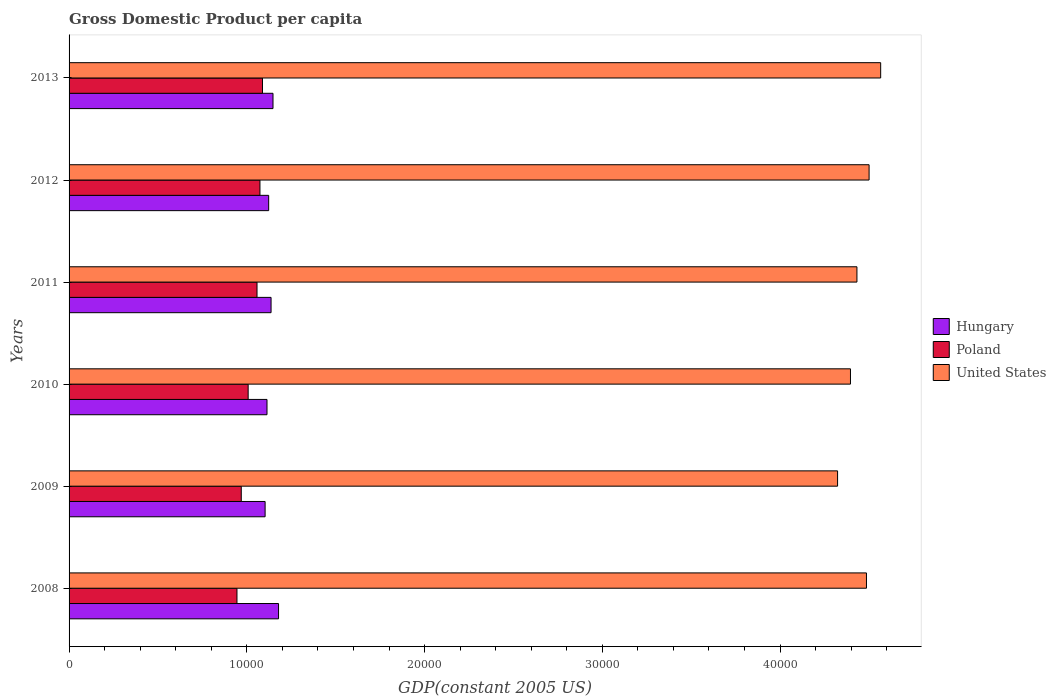Are the number of bars on each tick of the Y-axis equal?
Provide a short and direct response. Yes. How many bars are there on the 3rd tick from the top?
Your answer should be very brief. 3. How many bars are there on the 2nd tick from the bottom?
Offer a very short reply. 3. In how many cases, is the number of bars for a given year not equal to the number of legend labels?
Keep it short and to the point. 0. What is the GDP per capita in United States in 2011?
Provide a succinct answer. 4.43e+04. Across all years, what is the maximum GDP per capita in Poland?
Your answer should be compact. 1.09e+04. Across all years, what is the minimum GDP per capita in Hungary?
Provide a short and direct response. 1.10e+04. In which year was the GDP per capita in Poland minimum?
Make the answer very short. 2008. What is the total GDP per capita in Poland in the graph?
Offer a terse response. 6.14e+04. What is the difference between the GDP per capita in United States in 2009 and that in 2011?
Make the answer very short. -1089.39. What is the difference between the GDP per capita in Poland in 2009 and the GDP per capita in United States in 2013?
Provide a short and direct response. -3.60e+04. What is the average GDP per capita in Hungary per year?
Keep it short and to the point. 1.13e+04. In the year 2009, what is the difference between the GDP per capita in United States and GDP per capita in Poland?
Ensure brevity in your answer.  3.35e+04. What is the ratio of the GDP per capita in Poland in 2008 to that in 2012?
Keep it short and to the point. 0.88. Is the GDP per capita in Hungary in 2010 less than that in 2011?
Offer a very short reply. Yes. Is the difference between the GDP per capita in United States in 2010 and 2011 greater than the difference between the GDP per capita in Poland in 2010 and 2011?
Your answer should be very brief. Yes. What is the difference between the highest and the second highest GDP per capita in United States?
Offer a very short reply. 652.12. What is the difference between the highest and the lowest GDP per capita in United States?
Your answer should be compact. 2425.18. Is the sum of the GDP per capita in Hungary in 2009 and 2012 greater than the maximum GDP per capita in Poland across all years?
Provide a short and direct response. Yes. What does the 1st bar from the top in 2010 represents?
Offer a terse response. United States. What does the 2nd bar from the bottom in 2010 represents?
Your answer should be very brief. Poland. What is the difference between two consecutive major ticks on the X-axis?
Provide a short and direct response. 10000. Does the graph contain grids?
Keep it short and to the point. No. Where does the legend appear in the graph?
Your answer should be compact. Center right. How are the legend labels stacked?
Your answer should be very brief. Vertical. What is the title of the graph?
Your answer should be very brief. Gross Domestic Product per capita. Does "Greece" appear as one of the legend labels in the graph?
Offer a terse response. No. What is the label or title of the X-axis?
Keep it short and to the point. GDP(constant 2005 US). What is the label or title of the Y-axis?
Keep it short and to the point. Years. What is the GDP(constant 2005 US) in Hungary in 2008?
Make the answer very short. 1.18e+04. What is the GDP(constant 2005 US) in Poland in 2008?
Offer a very short reply. 9445.78. What is the GDP(constant 2005 US) in United States in 2008?
Ensure brevity in your answer.  4.49e+04. What is the GDP(constant 2005 US) of Hungary in 2009?
Ensure brevity in your answer.  1.10e+04. What is the GDP(constant 2005 US) of Poland in 2009?
Ensure brevity in your answer.  9688.03. What is the GDP(constant 2005 US) in United States in 2009?
Ensure brevity in your answer.  4.32e+04. What is the GDP(constant 2005 US) of Hungary in 2010?
Your answer should be compact. 1.11e+04. What is the GDP(constant 2005 US) in Poland in 2010?
Your answer should be compact. 1.01e+04. What is the GDP(constant 2005 US) in United States in 2010?
Give a very brief answer. 4.40e+04. What is the GDP(constant 2005 US) of Hungary in 2011?
Offer a very short reply. 1.14e+04. What is the GDP(constant 2005 US) in Poland in 2011?
Your answer should be very brief. 1.06e+04. What is the GDP(constant 2005 US) of United States in 2011?
Give a very brief answer. 4.43e+04. What is the GDP(constant 2005 US) in Hungary in 2012?
Give a very brief answer. 1.12e+04. What is the GDP(constant 2005 US) in Poland in 2012?
Your answer should be very brief. 1.07e+04. What is the GDP(constant 2005 US) in United States in 2012?
Offer a terse response. 4.50e+04. What is the GDP(constant 2005 US) in Hungary in 2013?
Keep it short and to the point. 1.15e+04. What is the GDP(constant 2005 US) of Poland in 2013?
Your answer should be very brief. 1.09e+04. What is the GDP(constant 2005 US) in United States in 2013?
Ensure brevity in your answer.  4.57e+04. Across all years, what is the maximum GDP(constant 2005 US) of Hungary?
Give a very brief answer. 1.18e+04. Across all years, what is the maximum GDP(constant 2005 US) in Poland?
Provide a short and direct response. 1.09e+04. Across all years, what is the maximum GDP(constant 2005 US) of United States?
Keep it short and to the point. 4.57e+04. Across all years, what is the minimum GDP(constant 2005 US) of Hungary?
Offer a terse response. 1.10e+04. Across all years, what is the minimum GDP(constant 2005 US) of Poland?
Give a very brief answer. 9445.78. Across all years, what is the minimum GDP(constant 2005 US) in United States?
Offer a terse response. 4.32e+04. What is the total GDP(constant 2005 US) in Hungary in the graph?
Ensure brevity in your answer.  6.80e+04. What is the total GDP(constant 2005 US) of Poland in the graph?
Keep it short and to the point. 6.14e+04. What is the total GDP(constant 2005 US) of United States in the graph?
Give a very brief answer. 2.67e+05. What is the difference between the GDP(constant 2005 US) in Hungary in 2008 and that in 2009?
Offer a very short reply. 755.89. What is the difference between the GDP(constant 2005 US) of Poland in 2008 and that in 2009?
Make the answer very short. -242.25. What is the difference between the GDP(constant 2005 US) of United States in 2008 and that in 2009?
Give a very brief answer. 1625.83. What is the difference between the GDP(constant 2005 US) in Hungary in 2008 and that in 2010?
Your response must be concise. 648.79. What is the difference between the GDP(constant 2005 US) in Poland in 2008 and that in 2010?
Offer a terse response. -629.33. What is the difference between the GDP(constant 2005 US) of United States in 2008 and that in 2010?
Provide a succinct answer. 900.22. What is the difference between the GDP(constant 2005 US) of Hungary in 2008 and that in 2011?
Offer a very short reply. 420.92. What is the difference between the GDP(constant 2005 US) of Poland in 2008 and that in 2011?
Offer a terse response. -1128.26. What is the difference between the GDP(constant 2005 US) of United States in 2008 and that in 2011?
Offer a terse response. 536.45. What is the difference between the GDP(constant 2005 US) of Hungary in 2008 and that in 2012?
Your response must be concise. 555. What is the difference between the GDP(constant 2005 US) of Poland in 2008 and that in 2012?
Give a very brief answer. -1293.42. What is the difference between the GDP(constant 2005 US) in United States in 2008 and that in 2012?
Ensure brevity in your answer.  -147.22. What is the difference between the GDP(constant 2005 US) of Hungary in 2008 and that in 2013?
Make the answer very short. 311.23. What is the difference between the GDP(constant 2005 US) in Poland in 2008 and that in 2013?
Make the answer very short. -1435.81. What is the difference between the GDP(constant 2005 US) of United States in 2008 and that in 2013?
Your answer should be very brief. -799.34. What is the difference between the GDP(constant 2005 US) in Hungary in 2009 and that in 2010?
Offer a terse response. -107.11. What is the difference between the GDP(constant 2005 US) of Poland in 2009 and that in 2010?
Make the answer very short. -387.08. What is the difference between the GDP(constant 2005 US) of United States in 2009 and that in 2010?
Give a very brief answer. -725.61. What is the difference between the GDP(constant 2005 US) of Hungary in 2009 and that in 2011?
Ensure brevity in your answer.  -334.97. What is the difference between the GDP(constant 2005 US) in Poland in 2009 and that in 2011?
Offer a very short reply. -886.01. What is the difference between the GDP(constant 2005 US) of United States in 2009 and that in 2011?
Give a very brief answer. -1089.39. What is the difference between the GDP(constant 2005 US) of Hungary in 2009 and that in 2012?
Offer a terse response. -200.9. What is the difference between the GDP(constant 2005 US) in Poland in 2009 and that in 2012?
Your answer should be compact. -1051.17. What is the difference between the GDP(constant 2005 US) in United States in 2009 and that in 2012?
Your answer should be very brief. -1773.06. What is the difference between the GDP(constant 2005 US) in Hungary in 2009 and that in 2013?
Offer a very short reply. -444.66. What is the difference between the GDP(constant 2005 US) of Poland in 2009 and that in 2013?
Offer a terse response. -1193.55. What is the difference between the GDP(constant 2005 US) in United States in 2009 and that in 2013?
Your answer should be compact. -2425.18. What is the difference between the GDP(constant 2005 US) in Hungary in 2010 and that in 2011?
Your response must be concise. -227.87. What is the difference between the GDP(constant 2005 US) of Poland in 2010 and that in 2011?
Give a very brief answer. -498.93. What is the difference between the GDP(constant 2005 US) in United States in 2010 and that in 2011?
Make the answer very short. -363.78. What is the difference between the GDP(constant 2005 US) of Hungary in 2010 and that in 2012?
Offer a very short reply. -93.79. What is the difference between the GDP(constant 2005 US) in Poland in 2010 and that in 2012?
Provide a succinct answer. -664.09. What is the difference between the GDP(constant 2005 US) of United States in 2010 and that in 2012?
Provide a succinct answer. -1047.45. What is the difference between the GDP(constant 2005 US) in Hungary in 2010 and that in 2013?
Make the answer very short. -337.56. What is the difference between the GDP(constant 2005 US) in Poland in 2010 and that in 2013?
Offer a very short reply. -806.47. What is the difference between the GDP(constant 2005 US) of United States in 2010 and that in 2013?
Give a very brief answer. -1699.57. What is the difference between the GDP(constant 2005 US) of Hungary in 2011 and that in 2012?
Provide a short and direct response. 134.08. What is the difference between the GDP(constant 2005 US) in Poland in 2011 and that in 2012?
Offer a terse response. -165.16. What is the difference between the GDP(constant 2005 US) in United States in 2011 and that in 2012?
Provide a short and direct response. -683.67. What is the difference between the GDP(constant 2005 US) of Hungary in 2011 and that in 2013?
Your response must be concise. -109.69. What is the difference between the GDP(constant 2005 US) in Poland in 2011 and that in 2013?
Ensure brevity in your answer.  -307.55. What is the difference between the GDP(constant 2005 US) in United States in 2011 and that in 2013?
Make the answer very short. -1335.79. What is the difference between the GDP(constant 2005 US) in Hungary in 2012 and that in 2013?
Your answer should be compact. -243.76. What is the difference between the GDP(constant 2005 US) in Poland in 2012 and that in 2013?
Your answer should be compact. -142.39. What is the difference between the GDP(constant 2005 US) in United States in 2012 and that in 2013?
Your answer should be compact. -652.12. What is the difference between the GDP(constant 2005 US) of Hungary in 2008 and the GDP(constant 2005 US) of Poland in 2009?
Offer a very short reply. 2096.6. What is the difference between the GDP(constant 2005 US) in Hungary in 2008 and the GDP(constant 2005 US) in United States in 2009?
Ensure brevity in your answer.  -3.15e+04. What is the difference between the GDP(constant 2005 US) in Poland in 2008 and the GDP(constant 2005 US) in United States in 2009?
Provide a succinct answer. -3.38e+04. What is the difference between the GDP(constant 2005 US) in Hungary in 2008 and the GDP(constant 2005 US) in Poland in 2010?
Your response must be concise. 1709.52. What is the difference between the GDP(constant 2005 US) of Hungary in 2008 and the GDP(constant 2005 US) of United States in 2010?
Keep it short and to the point. -3.22e+04. What is the difference between the GDP(constant 2005 US) of Poland in 2008 and the GDP(constant 2005 US) of United States in 2010?
Provide a short and direct response. -3.45e+04. What is the difference between the GDP(constant 2005 US) of Hungary in 2008 and the GDP(constant 2005 US) of Poland in 2011?
Your answer should be compact. 1210.59. What is the difference between the GDP(constant 2005 US) of Hungary in 2008 and the GDP(constant 2005 US) of United States in 2011?
Your answer should be compact. -3.25e+04. What is the difference between the GDP(constant 2005 US) of Poland in 2008 and the GDP(constant 2005 US) of United States in 2011?
Make the answer very short. -3.49e+04. What is the difference between the GDP(constant 2005 US) in Hungary in 2008 and the GDP(constant 2005 US) in Poland in 2012?
Your answer should be very brief. 1045.43. What is the difference between the GDP(constant 2005 US) in Hungary in 2008 and the GDP(constant 2005 US) in United States in 2012?
Your answer should be very brief. -3.32e+04. What is the difference between the GDP(constant 2005 US) in Poland in 2008 and the GDP(constant 2005 US) in United States in 2012?
Your answer should be very brief. -3.56e+04. What is the difference between the GDP(constant 2005 US) of Hungary in 2008 and the GDP(constant 2005 US) of Poland in 2013?
Provide a short and direct response. 903.04. What is the difference between the GDP(constant 2005 US) in Hungary in 2008 and the GDP(constant 2005 US) in United States in 2013?
Give a very brief answer. -3.39e+04. What is the difference between the GDP(constant 2005 US) of Poland in 2008 and the GDP(constant 2005 US) of United States in 2013?
Ensure brevity in your answer.  -3.62e+04. What is the difference between the GDP(constant 2005 US) in Hungary in 2009 and the GDP(constant 2005 US) in Poland in 2010?
Make the answer very short. 953.62. What is the difference between the GDP(constant 2005 US) of Hungary in 2009 and the GDP(constant 2005 US) of United States in 2010?
Provide a succinct answer. -3.29e+04. What is the difference between the GDP(constant 2005 US) in Poland in 2009 and the GDP(constant 2005 US) in United States in 2010?
Your answer should be compact. -3.43e+04. What is the difference between the GDP(constant 2005 US) of Hungary in 2009 and the GDP(constant 2005 US) of Poland in 2011?
Offer a very short reply. 454.7. What is the difference between the GDP(constant 2005 US) of Hungary in 2009 and the GDP(constant 2005 US) of United States in 2011?
Give a very brief answer. -3.33e+04. What is the difference between the GDP(constant 2005 US) of Poland in 2009 and the GDP(constant 2005 US) of United States in 2011?
Provide a short and direct response. -3.46e+04. What is the difference between the GDP(constant 2005 US) in Hungary in 2009 and the GDP(constant 2005 US) in Poland in 2012?
Your answer should be compact. 289.54. What is the difference between the GDP(constant 2005 US) of Hungary in 2009 and the GDP(constant 2005 US) of United States in 2012?
Make the answer very short. -3.40e+04. What is the difference between the GDP(constant 2005 US) in Poland in 2009 and the GDP(constant 2005 US) in United States in 2012?
Give a very brief answer. -3.53e+04. What is the difference between the GDP(constant 2005 US) in Hungary in 2009 and the GDP(constant 2005 US) in Poland in 2013?
Keep it short and to the point. 147.15. What is the difference between the GDP(constant 2005 US) in Hungary in 2009 and the GDP(constant 2005 US) in United States in 2013?
Provide a short and direct response. -3.46e+04. What is the difference between the GDP(constant 2005 US) of Poland in 2009 and the GDP(constant 2005 US) of United States in 2013?
Provide a succinct answer. -3.60e+04. What is the difference between the GDP(constant 2005 US) of Hungary in 2010 and the GDP(constant 2005 US) of Poland in 2011?
Offer a terse response. 561.8. What is the difference between the GDP(constant 2005 US) of Hungary in 2010 and the GDP(constant 2005 US) of United States in 2011?
Provide a succinct answer. -3.32e+04. What is the difference between the GDP(constant 2005 US) of Poland in 2010 and the GDP(constant 2005 US) of United States in 2011?
Your answer should be compact. -3.42e+04. What is the difference between the GDP(constant 2005 US) in Hungary in 2010 and the GDP(constant 2005 US) in Poland in 2012?
Offer a terse response. 396.64. What is the difference between the GDP(constant 2005 US) in Hungary in 2010 and the GDP(constant 2005 US) in United States in 2012?
Your response must be concise. -3.39e+04. What is the difference between the GDP(constant 2005 US) in Poland in 2010 and the GDP(constant 2005 US) in United States in 2012?
Keep it short and to the point. -3.49e+04. What is the difference between the GDP(constant 2005 US) in Hungary in 2010 and the GDP(constant 2005 US) in Poland in 2013?
Your response must be concise. 254.25. What is the difference between the GDP(constant 2005 US) of Hungary in 2010 and the GDP(constant 2005 US) of United States in 2013?
Make the answer very short. -3.45e+04. What is the difference between the GDP(constant 2005 US) in Poland in 2010 and the GDP(constant 2005 US) in United States in 2013?
Ensure brevity in your answer.  -3.56e+04. What is the difference between the GDP(constant 2005 US) of Hungary in 2011 and the GDP(constant 2005 US) of Poland in 2012?
Offer a terse response. 624.51. What is the difference between the GDP(constant 2005 US) in Hungary in 2011 and the GDP(constant 2005 US) in United States in 2012?
Your answer should be very brief. -3.36e+04. What is the difference between the GDP(constant 2005 US) in Poland in 2011 and the GDP(constant 2005 US) in United States in 2012?
Offer a very short reply. -3.44e+04. What is the difference between the GDP(constant 2005 US) of Hungary in 2011 and the GDP(constant 2005 US) of Poland in 2013?
Offer a very short reply. 482.12. What is the difference between the GDP(constant 2005 US) in Hungary in 2011 and the GDP(constant 2005 US) in United States in 2013?
Ensure brevity in your answer.  -3.43e+04. What is the difference between the GDP(constant 2005 US) in Poland in 2011 and the GDP(constant 2005 US) in United States in 2013?
Ensure brevity in your answer.  -3.51e+04. What is the difference between the GDP(constant 2005 US) of Hungary in 2012 and the GDP(constant 2005 US) of Poland in 2013?
Keep it short and to the point. 348.05. What is the difference between the GDP(constant 2005 US) in Hungary in 2012 and the GDP(constant 2005 US) in United States in 2013?
Give a very brief answer. -3.44e+04. What is the difference between the GDP(constant 2005 US) of Poland in 2012 and the GDP(constant 2005 US) of United States in 2013?
Give a very brief answer. -3.49e+04. What is the average GDP(constant 2005 US) of Hungary per year?
Offer a very short reply. 1.13e+04. What is the average GDP(constant 2005 US) of Poland per year?
Your answer should be very brief. 1.02e+04. What is the average GDP(constant 2005 US) in United States per year?
Keep it short and to the point. 4.45e+04. In the year 2008, what is the difference between the GDP(constant 2005 US) of Hungary and GDP(constant 2005 US) of Poland?
Offer a very short reply. 2338.85. In the year 2008, what is the difference between the GDP(constant 2005 US) of Hungary and GDP(constant 2005 US) of United States?
Offer a very short reply. -3.31e+04. In the year 2008, what is the difference between the GDP(constant 2005 US) of Poland and GDP(constant 2005 US) of United States?
Offer a very short reply. -3.54e+04. In the year 2009, what is the difference between the GDP(constant 2005 US) of Hungary and GDP(constant 2005 US) of Poland?
Make the answer very short. 1340.7. In the year 2009, what is the difference between the GDP(constant 2005 US) of Hungary and GDP(constant 2005 US) of United States?
Give a very brief answer. -3.22e+04. In the year 2009, what is the difference between the GDP(constant 2005 US) of Poland and GDP(constant 2005 US) of United States?
Ensure brevity in your answer.  -3.35e+04. In the year 2010, what is the difference between the GDP(constant 2005 US) of Hungary and GDP(constant 2005 US) of Poland?
Offer a very short reply. 1060.73. In the year 2010, what is the difference between the GDP(constant 2005 US) in Hungary and GDP(constant 2005 US) in United States?
Offer a very short reply. -3.28e+04. In the year 2010, what is the difference between the GDP(constant 2005 US) of Poland and GDP(constant 2005 US) of United States?
Provide a short and direct response. -3.39e+04. In the year 2011, what is the difference between the GDP(constant 2005 US) in Hungary and GDP(constant 2005 US) in Poland?
Ensure brevity in your answer.  789.67. In the year 2011, what is the difference between the GDP(constant 2005 US) in Hungary and GDP(constant 2005 US) in United States?
Keep it short and to the point. -3.30e+04. In the year 2011, what is the difference between the GDP(constant 2005 US) of Poland and GDP(constant 2005 US) of United States?
Offer a terse response. -3.38e+04. In the year 2012, what is the difference between the GDP(constant 2005 US) of Hungary and GDP(constant 2005 US) of Poland?
Make the answer very short. 490.43. In the year 2012, what is the difference between the GDP(constant 2005 US) of Hungary and GDP(constant 2005 US) of United States?
Your response must be concise. -3.38e+04. In the year 2012, what is the difference between the GDP(constant 2005 US) of Poland and GDP(constant 2005 US) of United States?
Give a very brief answer. -3.43e+04. In the year 2013, what is the difference between the GDP(constant 2005 US) of Hungary and GDP(constant 2005 US) of Poland?
Your answer should be very brief. 591.81. In the year 2013, what is the difference between the GDP(constant 2005 US) in Hungary and GDP(constant 2005 US) in United States?
Give a very brief answer. -3.42e+04. In the year 2013, what is the difference between the GDP(constant 2005 US) of Poland and GDP(constant 2005 US) of United States?
Provide a short and direct response. -3.48e+04. What is the ratio of the GDP(constant 2005 US) in Hungary in 2008 to that in 2009?
Your response must be concise. 1.07. What is the ratio of the GDP(constant 2005 US) in Poland in 2008 to that in 2009?
Your response must be concise. 0.97. What is the ratio of the GDP(constant 2005 US) of United States in 2008 to that in 2009?
Ensure brevity in your answer.  1.04. What is the ratio of the GDP(constant 2005 US) of Hungary in 2008 to that in 2010?
Your answer should be very brief. 1.06. What is the ratio of the GDP(constant 2005 US) of United States in 2008 to that in 2010?
Your answer should be very brief. 1.02. What is the ratio of the GDP(constant 2005 US) in Poland in 2008 to that in 2011?
Your response must be concise. 0.89. What is the ratio of the GDP(constant 2005 US) in United States in 2008 to that in 2011?
Your answer should be compact. 1.01. What is the ratio of the GDP(constant 2005 US) in Hungary in 2008 to that in 2012?
Give a very brief answer. 1.05. What is the ratio of the GDP(constant 2005 US) of Poland in 2008 to that in 2012?
Offer a terse response. 0.88. What is the ratio of the GDP(constant 2005 US) in Hungary in 2008 to that in 2013?
Offer a very short reply. 1.03. What is the ratio of the GDP(constant 2005 US) of Poland in 2008 to that in 2013?
Offer a terse response. 0.87. What is the ratio of the GDP(constant 2005 US) of United States in 2008 to that in 2013?
Give a very brief answer. 0.98. What is the ratio of the GDP(constant 2005 US) of Poland in 2009 to that in 2010?
Offer a very short reply. 0.96. What is the ratio of the GDP(constant 2005 US) in United States in 2009 to that in 2010?
Ensure brevity in your answer.  0.98. What is the ratio of the GDP(constant 2005 US) in Hungary in 2009 to that in 2011?
Offer a terse response. 0.97. What is the ratio of the GDP(constant 2005 US) of Poland in 2009 to that in 2011?
Provide a short and direct response. 0.92. What is the ratio of the GDP(constant 2005 US) in United States in 2009 to that in 2011?
Offer a terse response. 0.98. What is the ratio of the GDP(constant 2005 US) of Hungary in 2009 to that in 2012?
Give a very brief answer. 0.98. What is the ratio of the GDP(constant 2005 US) in Poland in 2009 to that in 2012?
Keep it short and to the point. 0.9. What is the ratio of the GDP(constant 2005 US) of United States in 2009 to that in 2012?
Your response must be concise. 0.96. What is the ratio of the GDP(constant 2005 US) in Hungary in 2009 to that in 2013?
Give a very brief answer. 0.96. What is the ratio of the GDP(constant 2005 US) in Poland in 2009 to that in 2013?
Ensure brevity in your answer.  0.89. What is the ratio of the GDP(constant 2005 US) of United States in 2009 to that in 2013?
Offer a terse response. 0.95. What is the ratio of the GDP(constant 2005 US) in Hungary in 2010 to that in 2011?
Give a very brief answer. 0.98. What is the ratio of the GDP(constant 2005 US) of Poland in 2010 to that in 2011?
Offer a terse response. 0.95. What is the ratio of the GDP(constant 2005 US) of United States in 2010 to that in 2011?
Offer a terse response. 0.99. What is the ratio of the GDP(constant 2005 US) of Hungary in 2010 to that in 2012?
Keep it short and to the point. 0.99. What is the ratio of the GDP(constant 2005 US) of Poland in 2010 to that in 2012?
Keep it short and to the point. 0.94. What is the ratio of the GDP(constant 2005 US) in United States in 2010 to that in 2012?
Make the answer very short. 0.98. What is the ratio of the GDP(constant 2005 US) of Hungary in 2010 to that in 2013?
Your response must be concise. 0.97. What is the ratio of the GDP(constant 2005 US) of Poland in 2010 to that in 2013?
Your answer should be compact. 0.93. What is the ratio of the GDP(constant 2005 US) in United States in 2010 to that in 2013?
Give a very brief answer. 0.96. What is the ratio of the GDP(constant 2005 US) in Hungary in 2011 to that in 2012?
Keep it short and to the point. 1.01. What is the ratio of the GDP(constant 2005 US) of Poland in 2011 to that in 2012?
Your response must be concise. 0.98. What is the ratio of the GDP(constant 2005 US) in United States in 2011 to that in 2012?
Make the answer very short. 0.98. What is the ratio of the GDP(constant 2005 US) in Poland in 2011 to that in 2013?
Give a very brief answer. 0.97. What is the ratio of the GDP(constant 2005 US) of United States in 2011 to that in 2013?
Offer a very short reply. 0.97. What is the ratio of the GDP(constant 2005 US) of Hungary in 2012 to that in 2013?
Provide a succinct answer. 0.98. What is the ratio of the GDP(constant 2005 US) in Poland in 2012 to that in 2013?
Provide a short and direct response. 0.99. What is the ratio of the GDP(constant 2005 US) in United States in 2012 to that in 2013?
Ensure brevity in your answer.  0.99. What is the difference between the highest and the second highest GDP(constant 2005 US) in Hungary?
Offer a terse response. 311.23. What is the difference between the highest and the second highest GDP(constant 2005 US) of Poland?
Your answer should be compact. 142.39. What is the difference between the highest and the second highest GDP(constant 2005 US) of United States?
Offer a terse response. 652.12. What is the difference between the highest and the lowest GDP(constant 2005 US) in Hungary?
Ensure brevity in your answer.  755.89. What is the difference between the highest and the lowest GDP(constant 2005 US) of Poland?
Provide a succinct answer. 1435.81. What is the difference between the highest and the lowest GDP(constant 2005 US) in United States?
Your response must be concise. 2425.18. 